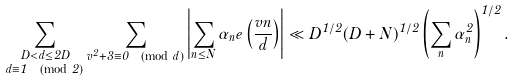Convert formula to latex. <formula><loc_0><loc_0><loc_500><loc_500>\underset { d \equiv 1 \pmod { 2 } } { \sum _ { D < d \leq 2 D } } \sum _ { v ^ { 2 } + 3 \equiv 0 \pmod { d } } \left | \sum _ { n \leq N } \alpha _ { n } e \left ( \frac { v n } { d } \right ) \right | \ll D ^ { 1 / 2 } ( D + N ) ^ { 1 / 2 } \left ( \sum _ { n } \alpha _ { n } ^ { 2 } \right ) ^ { 1 / 2 } .</formula> 